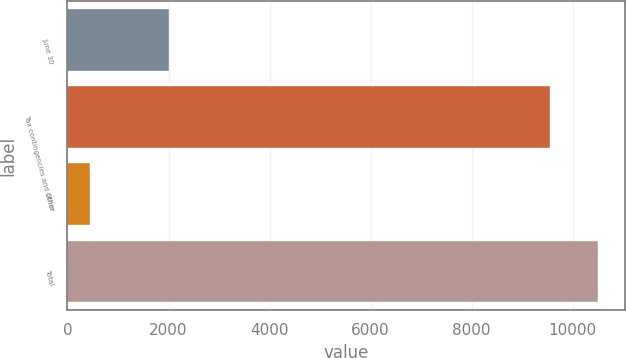Convert chart to OTSL. <chart><loc_0><loc_0><loc_500><loc_500><bar_chart><fcel>June 30<fcel>Tax contingencies and other<fcel>Other<fcel>Total<nl><fcel>2013<fcel>9548<fcel>452<fcel>10502.8<nl></chart> 